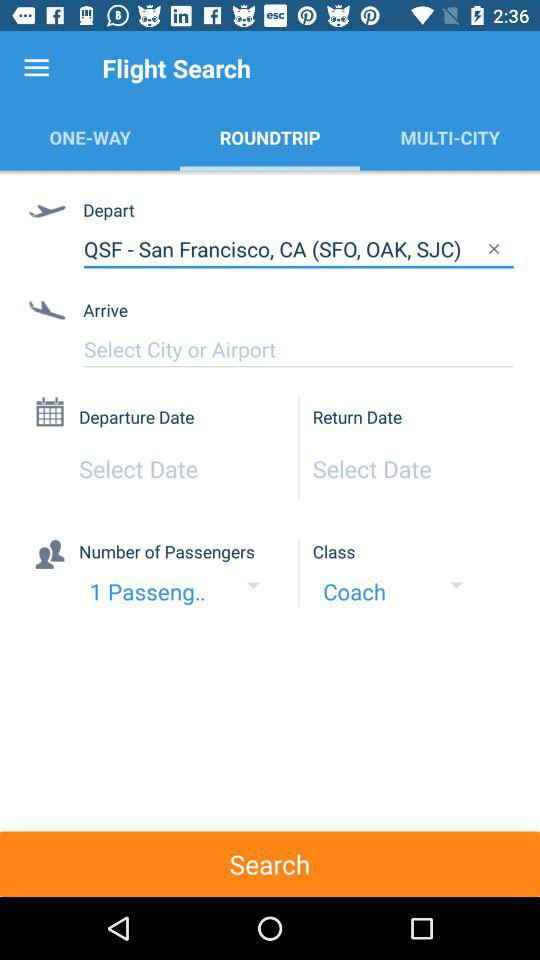How many more text inputs are there for the departure and return dates than the number of passengers?
Answer the question using a single word or phrase. 1 